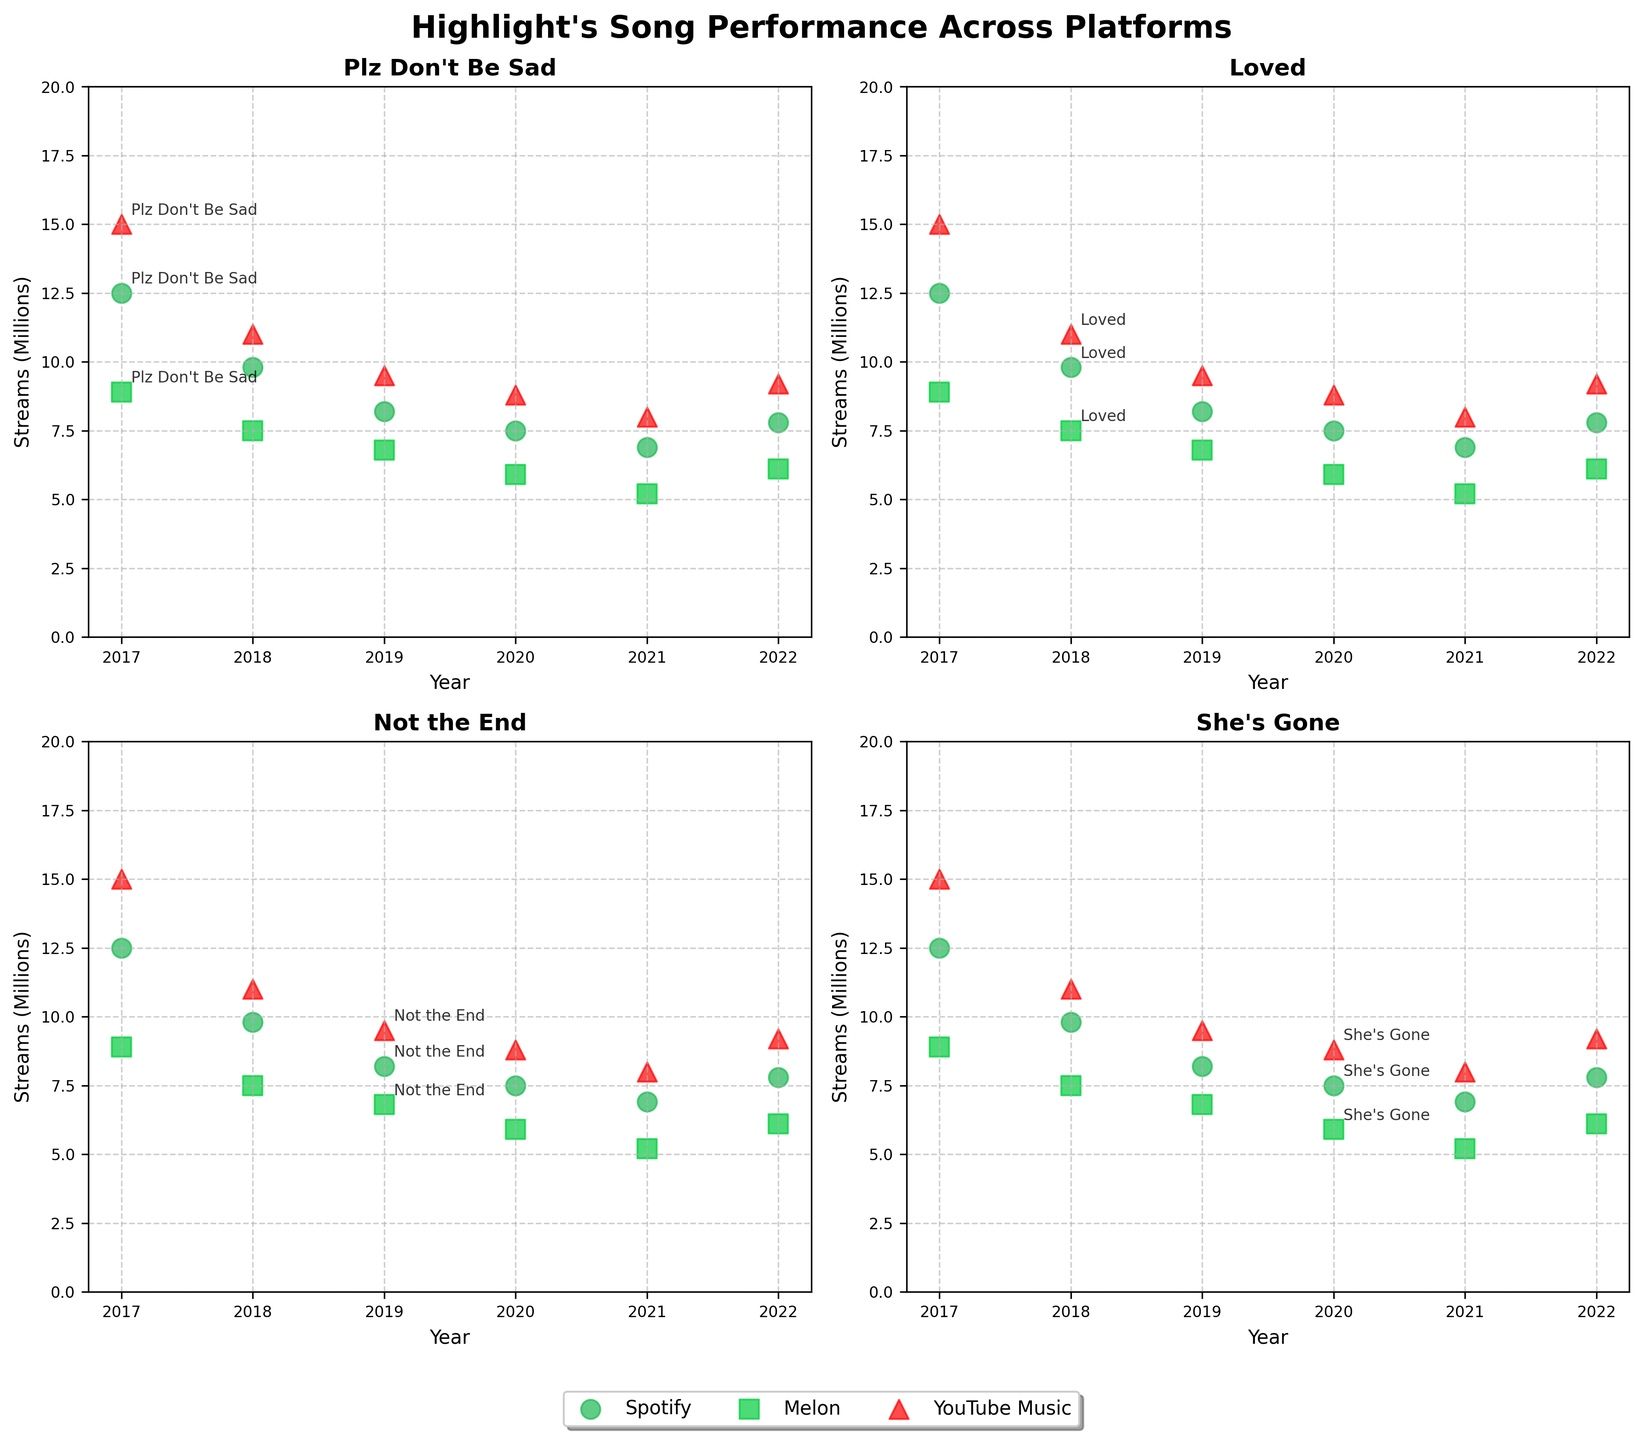What is the title of the figure? The title of the figure is displayed prominently at the top, and it reads, "Highlight's Song Performance Across Platforms."
Answer: Highlight's Song Performance Across Platforms Which platform has the highest number of streams for the song "Plz Don't Be Sad" in 2017? By looking at the subplot for "Plz Don't Be Sad," we can visually identify the point with the highest position on the y-axis in 2017. The color and shape of the point indicate the platform, which is red with a triangle marker for YouTube Music.
Answer: YouTube Music Among all the songs, which year shows the lowest streaming numbers on Melon? By observing the y-axis values for the green square markers across all subplots, we see that the year with the lowest position on the plot (indicating the lowest stream numbers) is 2021 for the song "The Blowing."
Answer: 2021 In which year did "Daydream" obtain the highest streaming numbers across all platforms, and what was the approximate value? Analyzing the "Daydream" subplot and focusing on the points in different years, the highest point appears in 2022. The corresponding y-axis value approximates to 9.2 million streams.
Answer: 2022, 9.2 million streams Which song shows the most consistent performance on Spotify from 2017 to 2022? By comparing the relative heights (y-values) of the green circle markers across years in each subplot, we notice that "Daydream" in 2022 on Spotify has very similar values, demonstrating consistent performance.
Answer: Daydream How do the streaming numbers for "She's Gone" on Spotify in 2020 compare to "The Blowing" on the same platform in 2021? By looking at the blue circle markers for 2020 and 2021, "She's Gone" in 2020 is higher on the y-axis than "The Blowing" in 2021, indicating "She's Gone" had more streams on Spotify that year.
Answer: Higher Which song experienced the most significant drop in streams on YouTube Music between two consecutive years? We look for the red triangle markers with the largest vertical drop between two consecutive years across all subplots. "Plz Don't Be Sad" from 2017 to 2018 shows the most significant decrease.
Answer: Plz Don't Be Sad What is the average number of streams in millions on Melon for the song "Loved" across the years? For "Loved" on Melon, first identify the green square points in the subplot for "Loved," then take the values for the years it appears: 7.5 million. Since it appears in one year, the average is simply this value.
Answer: 7.5 million Which platform generally shows the highest number of streams across different years and songs based on the figure? Observing the highest positioned markers in different colors and shapes throughout the subplots, red triangles for YouTube Music often appear at the highest points, indicating the most streams.
Answer: YouTube Music 